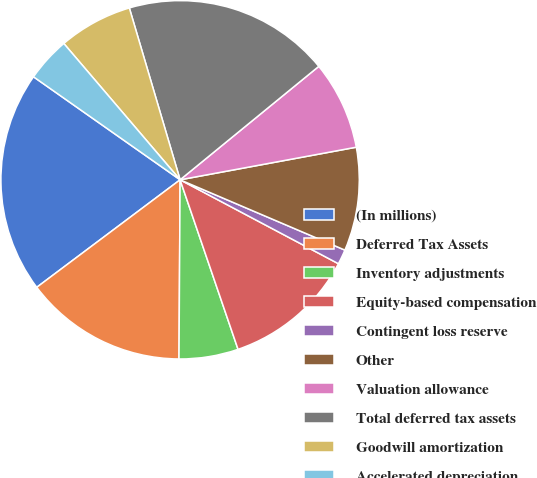<chart> <loc_0><loc_0><loc_500><loc_500><pie_chart><fcel>(In millions)<fcel>Deferred Tax Assets<fcel>Inventory adjustments<fcel>Equity-based compensation<fcel>Contingent loss reserve<fcel>Other<fcel>Valuation allowance<fcel>Total deferred tax assets<fcel>Goodwill amortization<fcel>Accelerated depreciation<nl><fcel>19.99%<fcel>14.66%<fcel>5.34%<fcel>12.0%<fcel>1.34%<fcel>9.33%<fcel>8.0%<fcel>18.66%<fcel>6.67%<fcel>4.01%<nl></chart> 